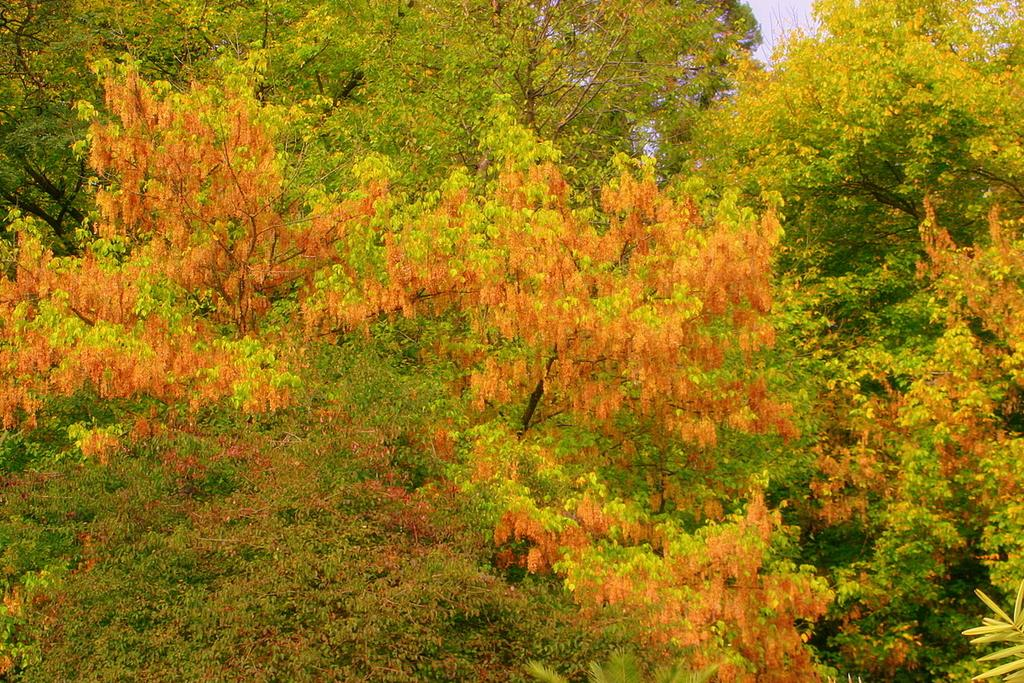What type of vegetation can be seen in the image? There are trees in the image. What other natural elements can be seen in the image? There are flowers in the image. What type of dress is the flower wearing in the image? There are no dresses or flowers wearing clothing in the image; the flowers are natural elements. 